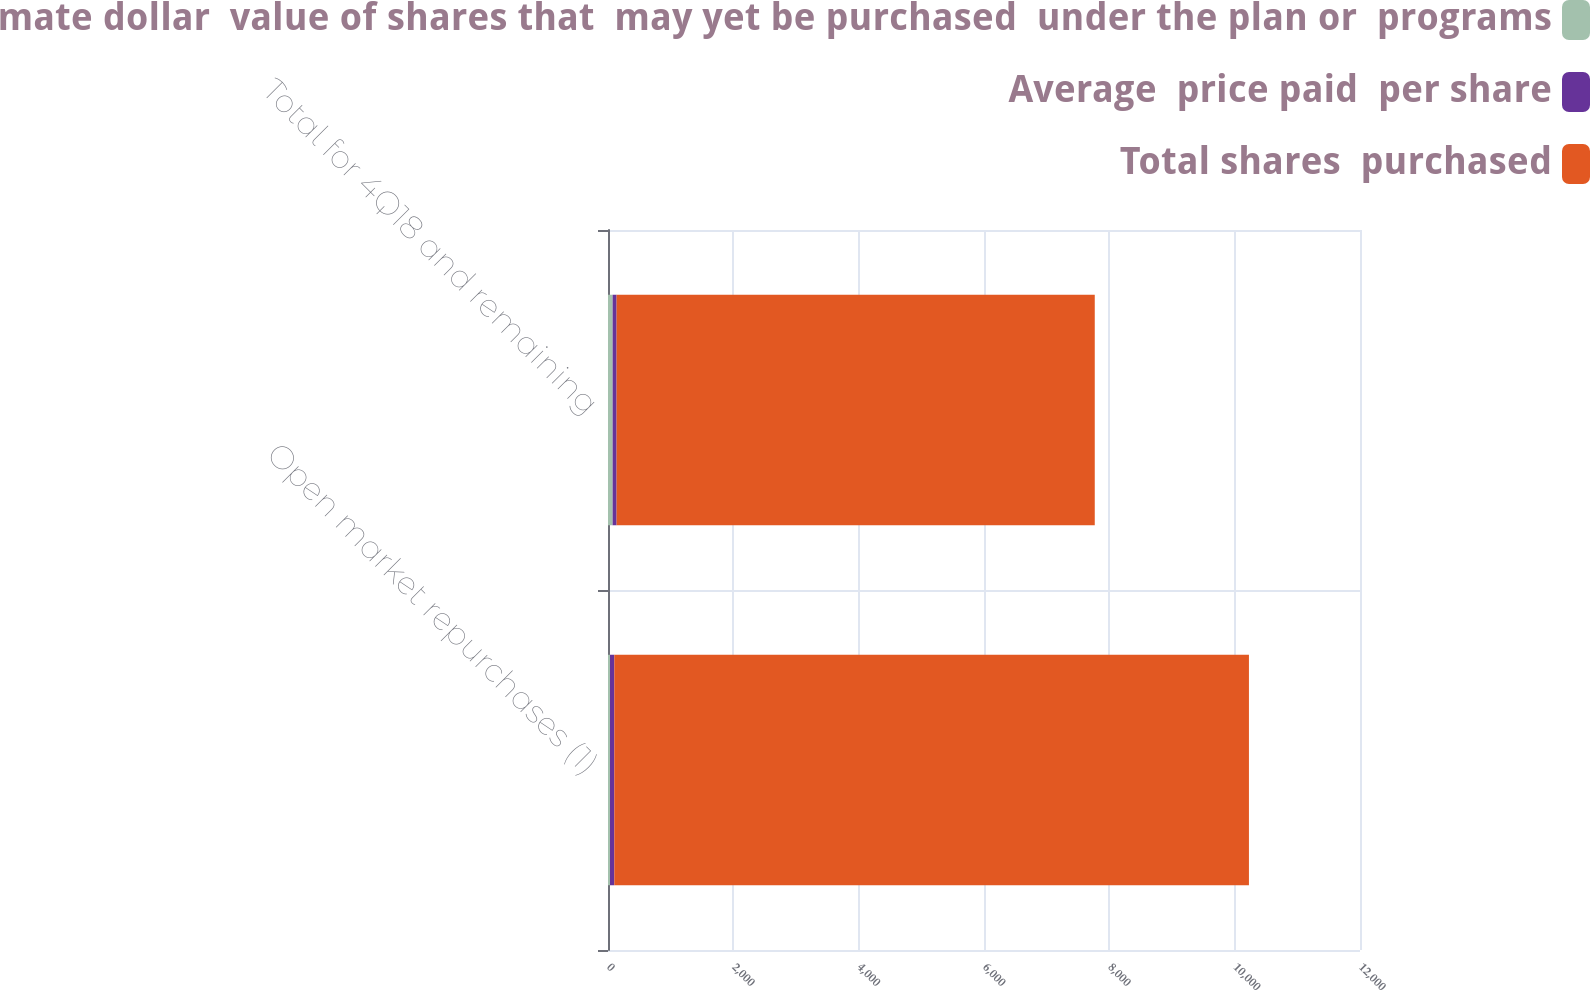<chart> <loc_0><loc_0><loc_500><loc_500><stacked_bar_chart><ecel><fcel>Open market repurchases (1)<fcel>Total for 4Q18 and remaining<nl><fcel>Approximate dollar  value of shares that  may yet be purchased  under the plan or  programs<fcel>32<fcel>73.8<nl><fcel>Average  price paid  per share<fcel>68.78<fcel>63.7<nl><fcel>Total shares  purchased<fcel>10127<fcel>7630<nl></chart> 